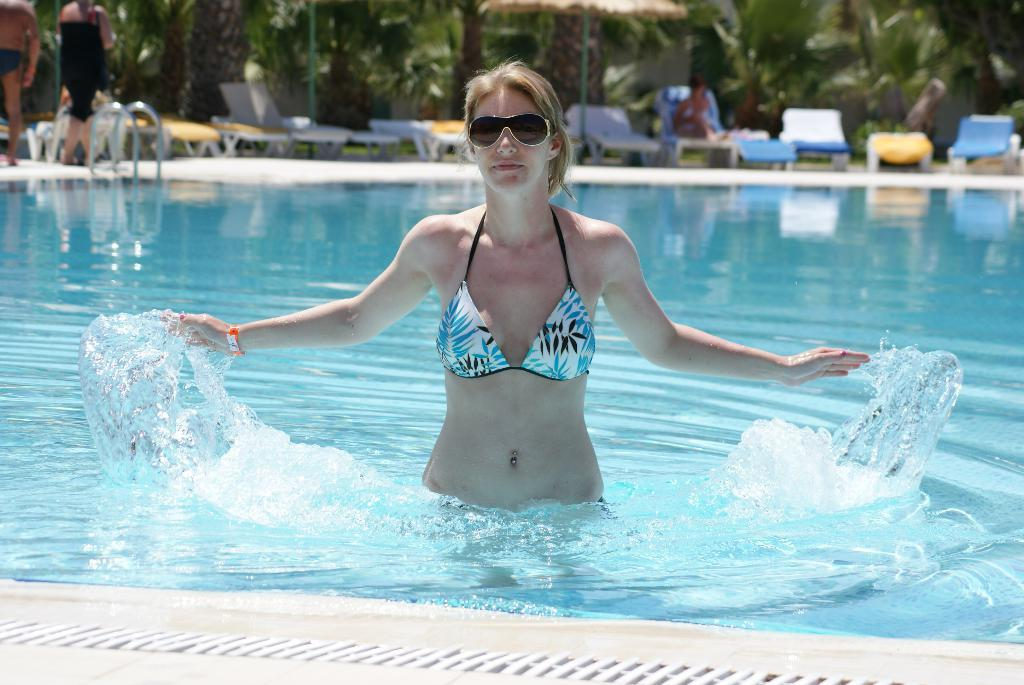Who is present in the image? There is a woman in the image. What is the woman wearing that is visible in the image? The woman is wearing spectacles. Where is the woman located in the image? The woman is standing in the water. What can be seen in the background of the image? There are chairs, metal rods, and trees in the background of the image. What time of day is it in the image? The provided facts do not mention the time of day, so it cannot be determined from the image. 